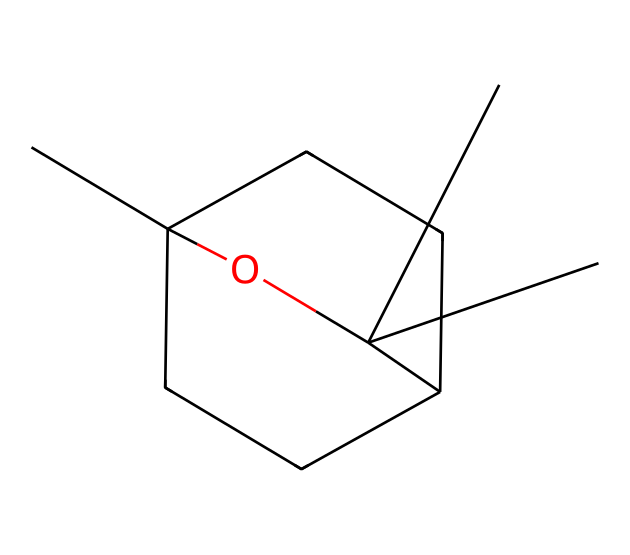What is the molecular formula of eucalyptol? To determine the molecular formula, we can count the number of carbon (C), hydrogen (H), and oxygen (O) atoms based on the SMILES representation. In this case, the SMILES indicates 10 carbon atoms, 18 hydrogen atoms, and 1 oxygen atom. Therefore, the molecular formula is C10H18O.
Answer: C10H18O How many rings are present in eucalyptol? By analyzing the structure represented by the SMILES, we note that there are two cyclic components, which indicates the presence of two rings in the eucalyptol structure.
Answer: 2 What type of functional group is found in eucalyptol? Looking at the SMILES, we can identify a hydroxyl (-OH) functional group accompanying the carbon framework. This indicates that eucalyptol is an alcohol.
Answer: alcohol What is the total number of atoms in eucalyptol? We calculate the total number of atoms by summing the individual atoms of carbon, hydrogen, and oxygen based on the molecular formula. That gives us 10 carbon, 18 hydrogen, and 1 oxygen, resulting in a total of 29 atoms.
Answer: 29 What is the hybridization of the carbon atoms in eucalyptol? The carbon atoms in eucalyptol primarily exhibit sp3 hybridization due to the presence of single bonds to other atoms, including other carbons and hydrogens. This is typical for saturated structures such as terpenes.
Answer: sp3 What is the significance of terpenes like eucalyptol in industrial applications? Terpenes, including eucalyptol, are commonly used for their aromatic properties and abilities to act as solvents or disinfectants, making them valuable in the production of air fresheners and disinfectants.
Answer: valuable Is eucalyptol considered a saturated or unsaturated compound? By examining the presence of double bonds in the structure, it is clear that eucalyptol contains only single bonds between carbon and hydrogen, classifying it as a saturated compound.
Answer: saturated 